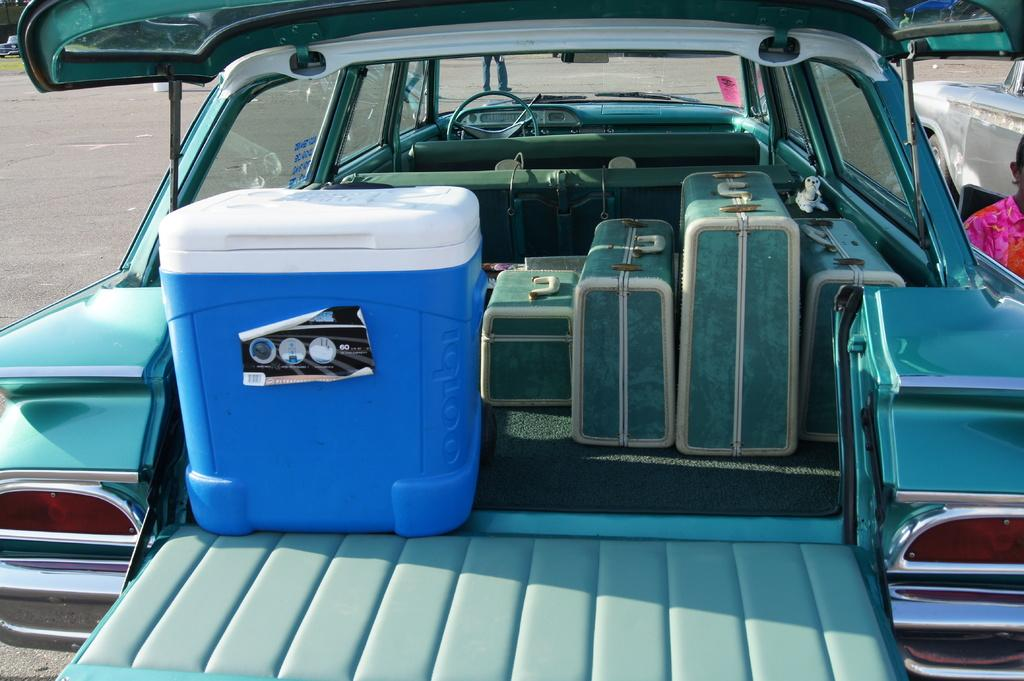What is the main subject of the image? The main subject of the image is a vehicle. What can be seen attached to the vehicle? The vehicle has luggage, including a suitcase and a box. Is there anyone near the vehicle? Yes, there is a person standing next to the vehicle. What can be seen in the distance behind the vehicle? There is a road visible in the background of the image. What type of brush is being used by the representative from the company in the image? There is no representative from a company or any brush present in the image. 